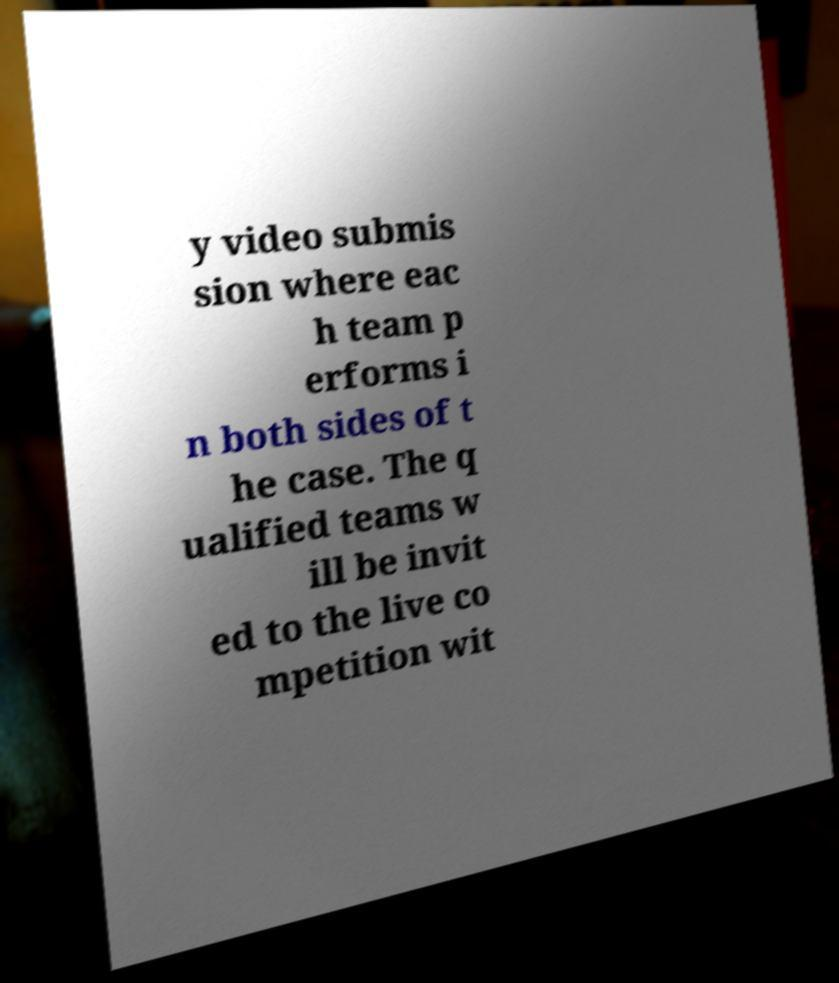What messages or text are displayed in this image? I need them in a readable, typed format. y video submis sion where eac h team p erforms i n both sides of t he case. The q ualified teams w ill be invit ed to the live co mpetition wit 